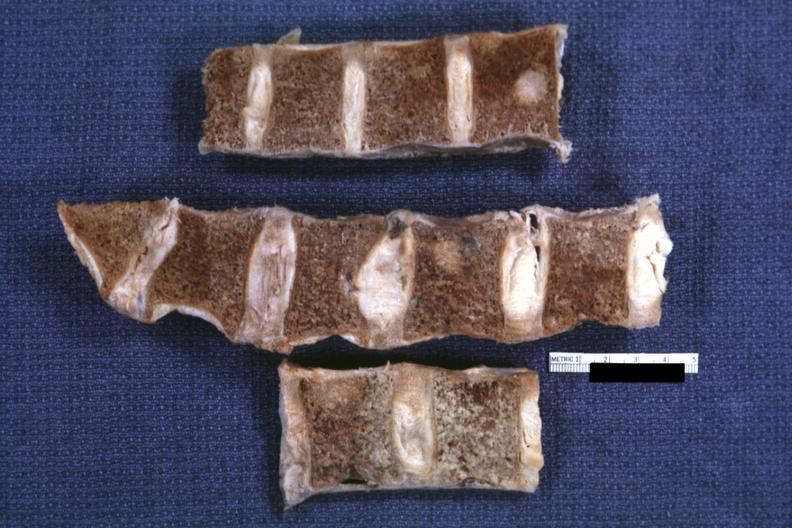what does this image show?
Answer the question using a single word or phrase. Fixed tissue well shown lesion in vertebral marrow lung adenoca 